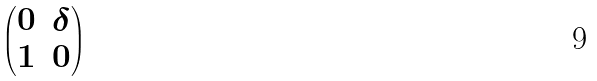Convert formula to latex. <formula><loc_0><loc_0><loc_500><loc_500>\begin{pmatrix} 0 & \delta \\ 1 & 0 \end{pmatrix}</formula> 